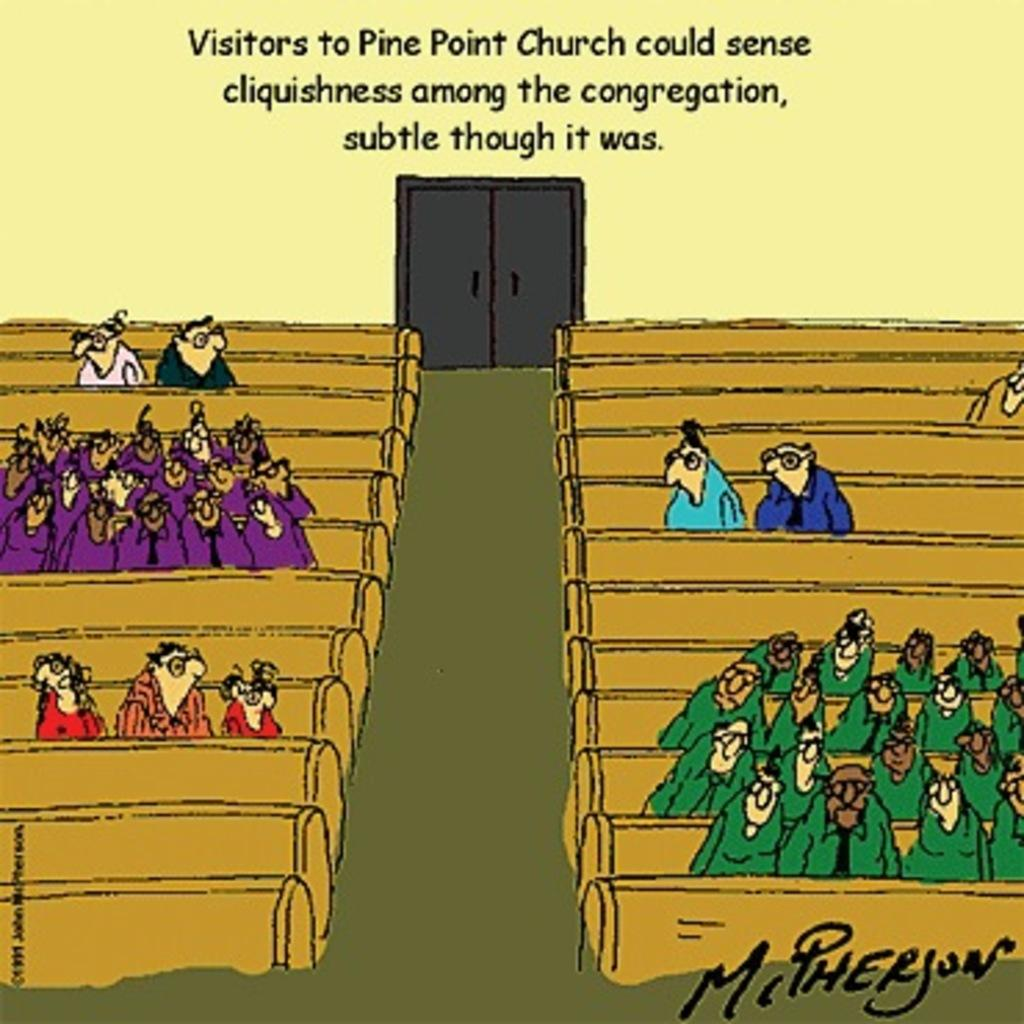What is the main subject of the poster in the image? The poster contains images of people, benches, a door, and a wall. What else can be found on the poster besides images? There is text on the poster. Can you tell me how many shoes are depicted on the poster? There are no shoes present on the poster; it features images of people, benches, a door, and a wall, along with text. What type of vegetable is shown growing on the wall in the image? There is no vegetable, such as cabbage, shown growing on the wall in the image; the poster only contains images of people, benches, a door, and a wall, along with text. 